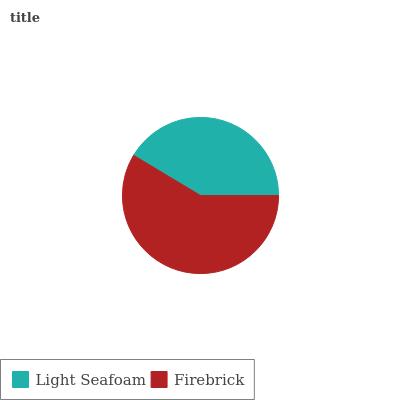Is Light Seafoam the minimum?
Answer yes or no. Yes. Is Firebrick the maximum?
Answer yes or no. Yes. Is Firebrick the minimum?
Answer yes or no. No. Is Firebrick greater than Light Seafoam?
Answer yes or no. Yes. Is Light Seafoam less than Firebrick?
Answer yes or no. Yes. Is Light Seafoam greater than Firebrick?
Answer yes or no. No. Is Firebrick less than Light Seafoam?
Answer yes or no. No. Is Firebrick the high median?
Answer yes or no. Yes. Is Light Seafoam the low median?
Answer yes or no. Yes. Is Light Seafoam the high median?
Answer yes or no. No. Is Firebrick the low median?
Answer yes or no. No. 